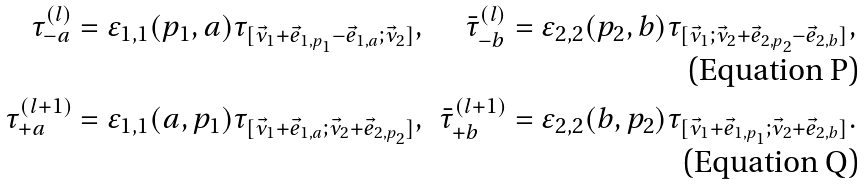<formula> <loc_0><loc_0><loc_500><loc_500>\tau ^ { ( l ) } _ { - a } & = \varepsilon _ { 1 , 1 } ( p _ { 1 } , a ) \tau _ { [ \vec { \nu } _ { 1 } + \vec { e } _ { 1 , p _ { 1 } } - \vec { e } _ { 1 , a } ; \vec { \nu } _ { 2 } ] } , & \bar { \tau } ^ { ( l ) } _ { - b } & = \varepsilon _ { 2 , 2 } ( p _ { 2 } , b ) \tau _ { [ \vec { \nu } _ { 1 } ; \vec { \nu } _ { 2 } + \vec { e } _ { 2 , p _ { 2 } } - \vec { e } _ { 2 , b } ] } , \\ \tau ^ { ( l + 1 ) } _ { + a } & = \varepsilon _ { 1 , 1 } ( a , p _ { 1 } ) \tau _ { [ \vec { \nu } _ { 1 } + \vec { e } _ { 1 , a } ; \vec { \nu } _ { 2 } + \vec { e } _ { 2 , p _ { 2 } } ] } , & \bar { \tau } ^ { ( l + 1 ) } _ { + b } & = \varepsilon _ { 2 , 2 } ( b , p _ { 2 } ) \tau _ { [ \vec { \nu } _ { 1 } + \vec { e } _ { 1 , p _ { 1 } } ; \vec { \nu } _ { 2 } + \vec { e } _ { 2 , b } ] } .</formula> 